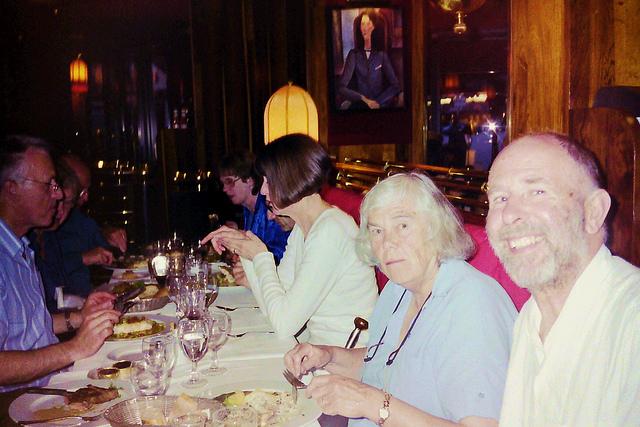What is around the lady's neck?
Concise answer only. Glasses. Is this a young people's gathering?
Be succinct. No. What are the people eating?
Concise answer only. Food. 